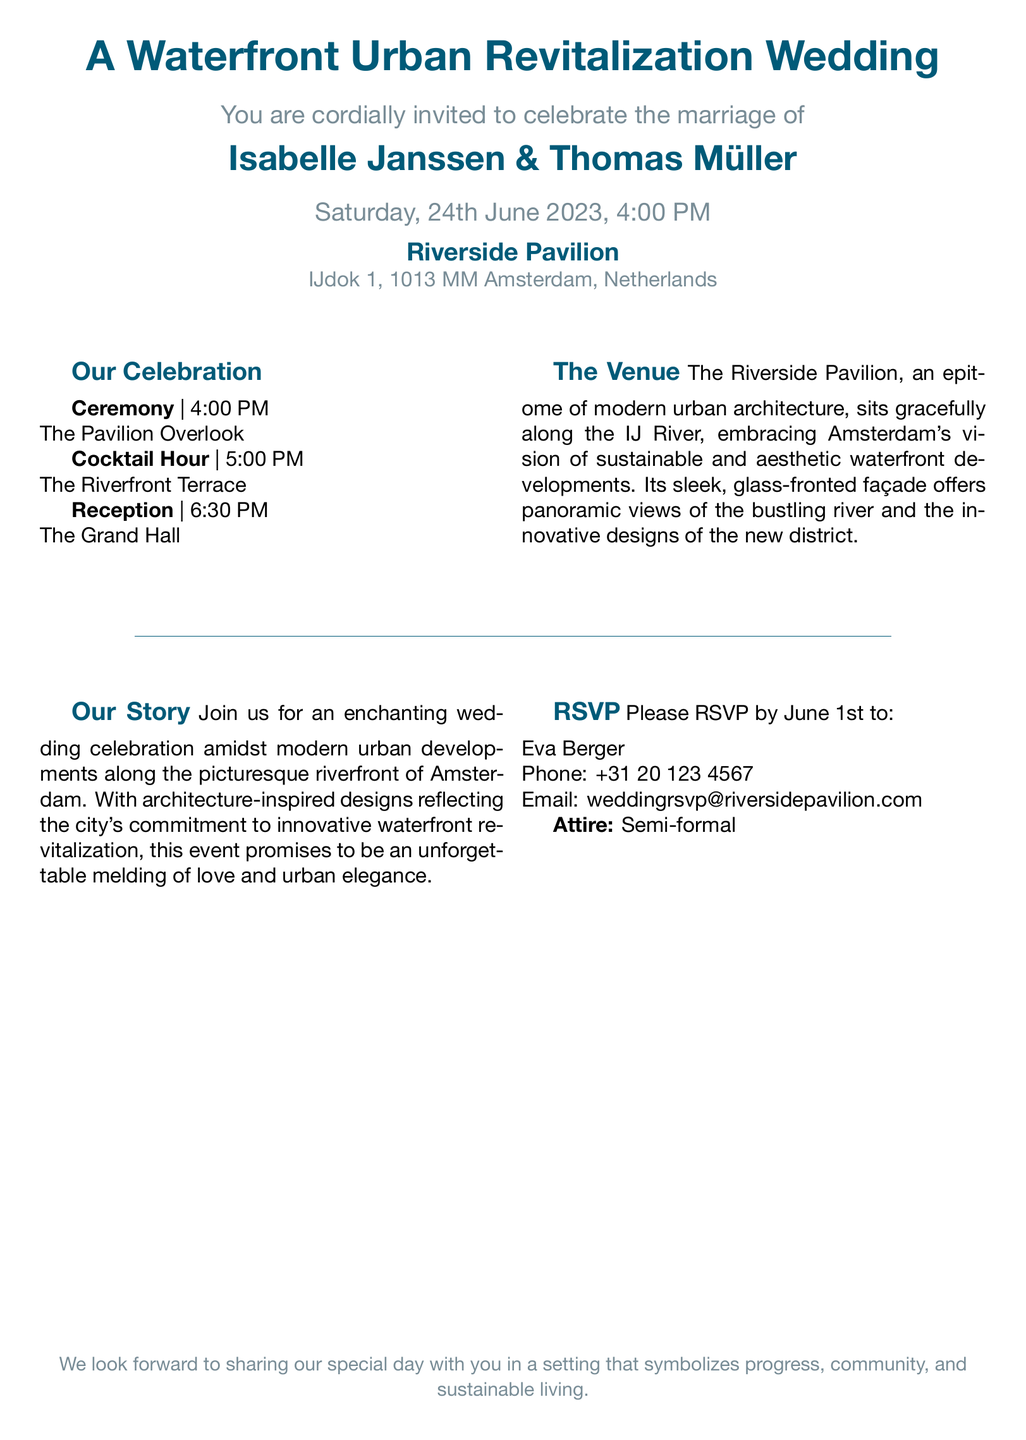What date is the wedding? The date of the wedding is explicitly mentioned in the invitation.
Answer: 24th June 2023 What time does the ceremony start? The ceremony's start time is listed in the schedule of events.
Answer: 4:00 PM Who are the couple getting married? The names of the couple are highlighted at the top of the invitation.
Answer: Isabelle Janssen & Thomas Müller What is the venue for the reception? The reception location is specified in the structured format of the invitation.
Answer: The Grand Hall What type of attire is requested? The attire information is noted under the RSVP section.
Answer: Semi-formal What does the Riverside Pavilion symbolize? The document mentions a symbolic aspect related to the venue.
Answer: Progress, community, and sustainable living Where is the Riverside Pavilion located? The location is provided in the address section of the invitation.
Answer: IJdok 1, 1013 MM Amsterdam, Netherlands What is mentioned about the venue's architecture? Information about the venue's architectural style is included in the description.
Answer: Modern urban architecture What is the purpose of the wedding celebration? The invite reveals a theme regarding the purpose of the celebration.
Answer: An enchanting wedding celebration 